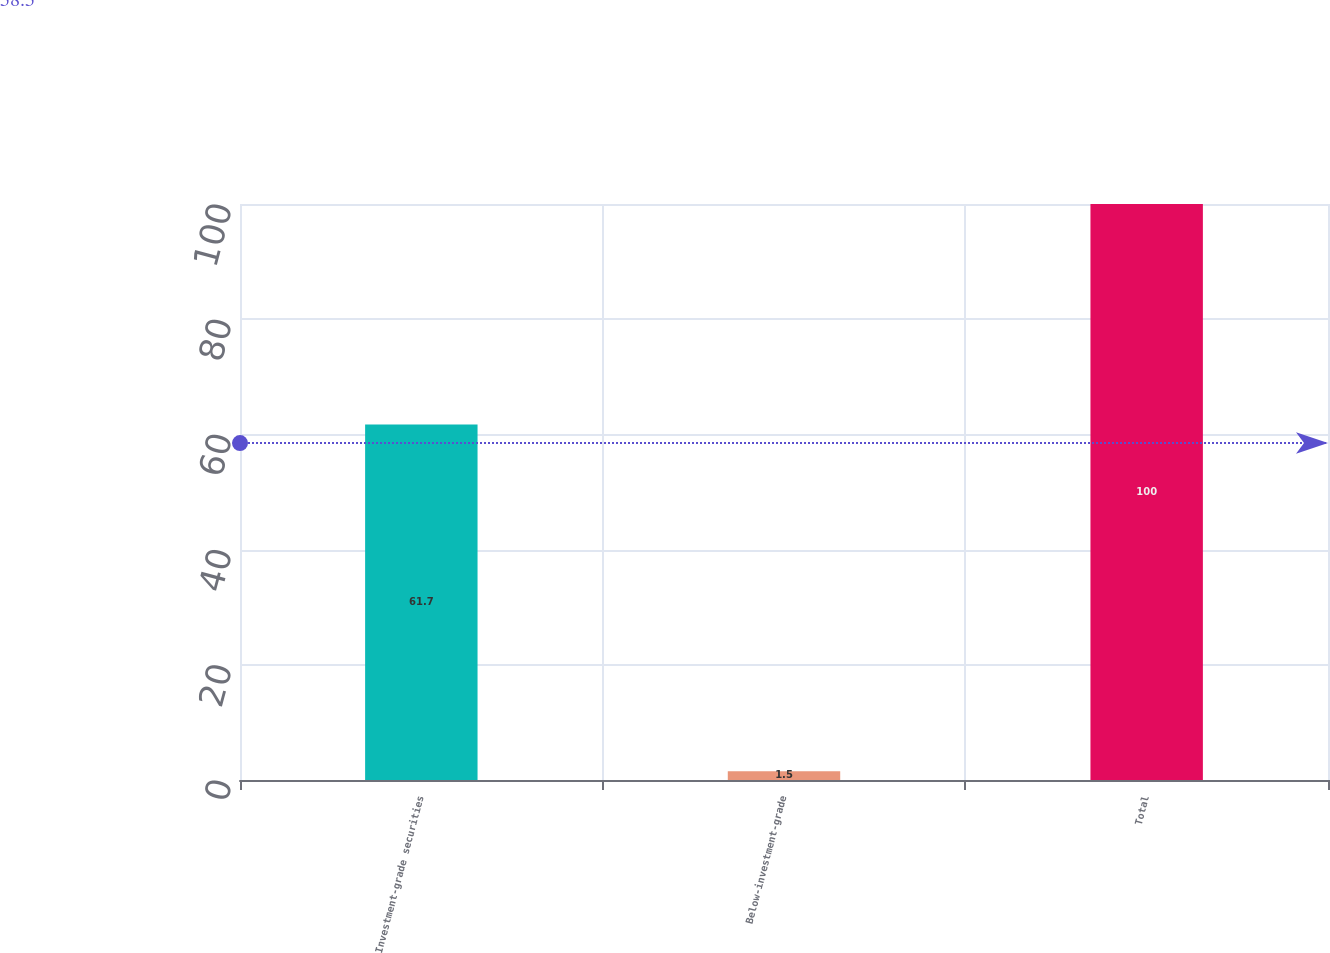<chart> <loc_0><loc_0><loc_500><loc_500><bar_chart><fcel>Investment-grade securities<fcel>Below-investment-grade<fcel>Total<nl><fcel>61.7<fcel>1.5<fcel>100<nl></chart> 